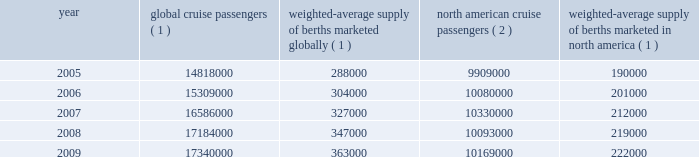The table details the growth in the global and north american cruise markets in terms of cruise passengers and estimated weighted-average berths over the past five years : we compete with a number of cruise lines ; however , our principal competitors are carnival corporation & plc , which owns , among others , aida cruises , carnival cruise lines , costa cruises , cunard line , holland america line , iberocruceros , p&o cruises and princess cruises ; disney cruise line ; msc cruises ; norwegian cruise line and oceania cruises .
Cruise lines compete with other vacation alternatives such as land-based resort hotels and sightseeing destinations for consumers 2019 leisure time .
Demand for such activities is influenced by political and general economic conditions .
Companies within the vacation market are dependent on consumer discretionary spending .
Our ships operate worldwide and have itineraries that call on destinations in alaska , asia , australia , the bahamas , bermuda , california , canada , the caribbean , europe , the galapagos islands , hawaii , mexico , the middle east , new england , new zealand , the panama canal and south america .
In an effort to penetrate untapped markets and diversify our customer base , we continue to seek opportunities to redeploy ships in our royal caribbean international , celebrity cruises and azamara club cruises brands to new markets and itineraries throughout the world .
The portability of our ships and our investment in infrastructure allows us to expand into new markets and helps us reduce our dependency on any one market by allowing us to create 201chome ports 201d around the world .
In addition , it allows us to readily redeploy our ships to meet demand within our existing cruise markets .
The current economic environment has significantly deteriorated consumer confidence and discretionary spending .
While there has been a decrease in the demand for cruises and a resulting drop in cruise prices , cruising has proven to be resilient as it offers consumers a good value when compared to other vacation alternatives .
However , the projected increase in capacity within the cruise industry from new cruise ships currently on order could produce additional pricing pressures within the industry .
See item 1a .
Risk factors .
Global cruise passengers ( 1 ) weighted-average supply of berths marketed globally ( 1 ) north american cruise passengers ( 2 ) weighted-average supply of berths marketed in america ( 1 ) .
1 ) source : our estimates of the number of global cruise passengers , and the weighted-average supply of berths marketed globally and in north america are based on a combination of data that we obtain from various publicly available cruise industry trade information sources including seatrade insider and cruise line international association .
In addition , our estimates incorporate our own statistical analysis utilizing the same publicly available cruise industry data as a base .
2 ) source : cruise line international association based on cruise passengers carried for at least two consecutive nights for years 2005 through 2008 .
Year 2009 amounts represent our estimates ( see number 1 above ) . .
In 2005 what was the percent of the weighted-average supply of berths marketed globally in the north america? 
Computations: (190000 / 288000)
Answer: 0.65972. 